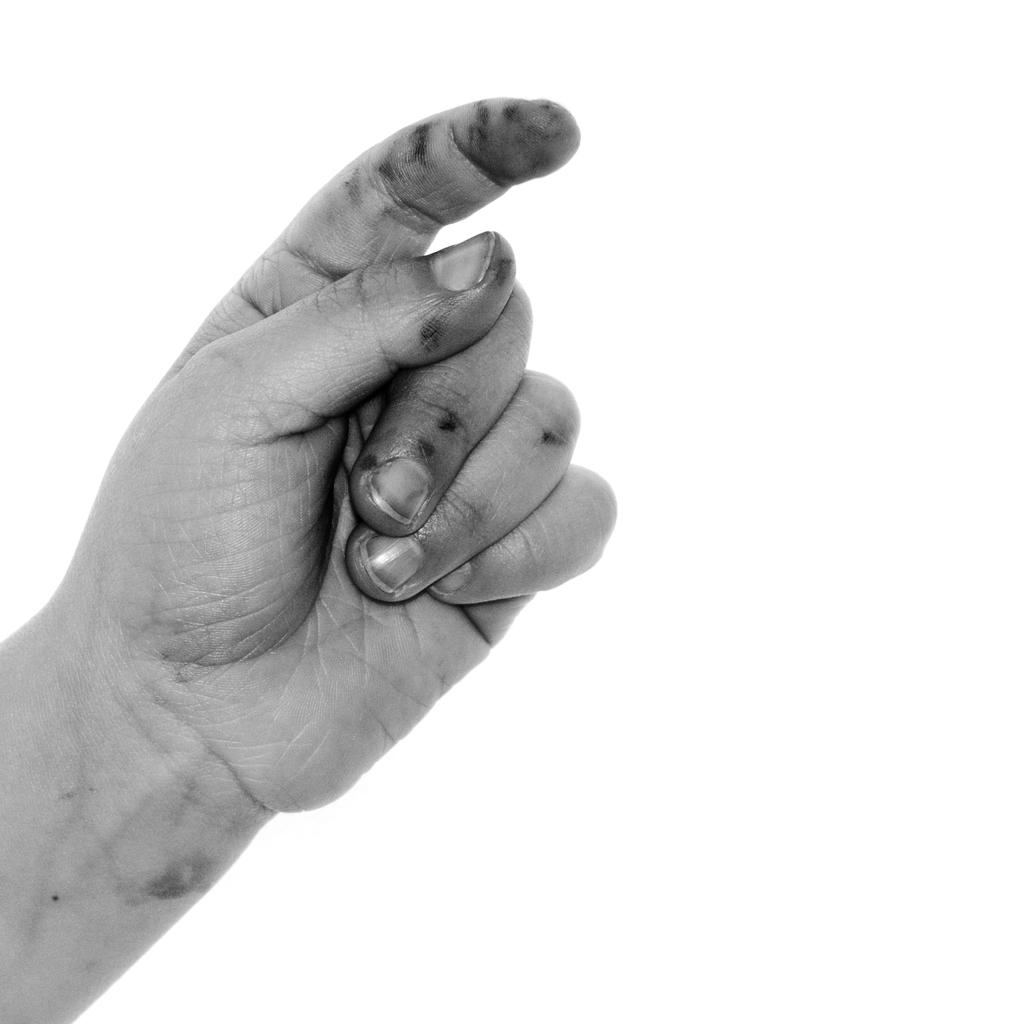What can be seen in the image? There is a person's hand in the image. What color is the background of the image? The background of the image is white. Can you tell if the image was taken during the day or night? The image was likely taken during the day, as there is no indication of darkness or artificial lighting. What type of grass can be seen growing out of the hole in the image? There is no grass or hole present in the image; it only features a person's hand against a white background. 